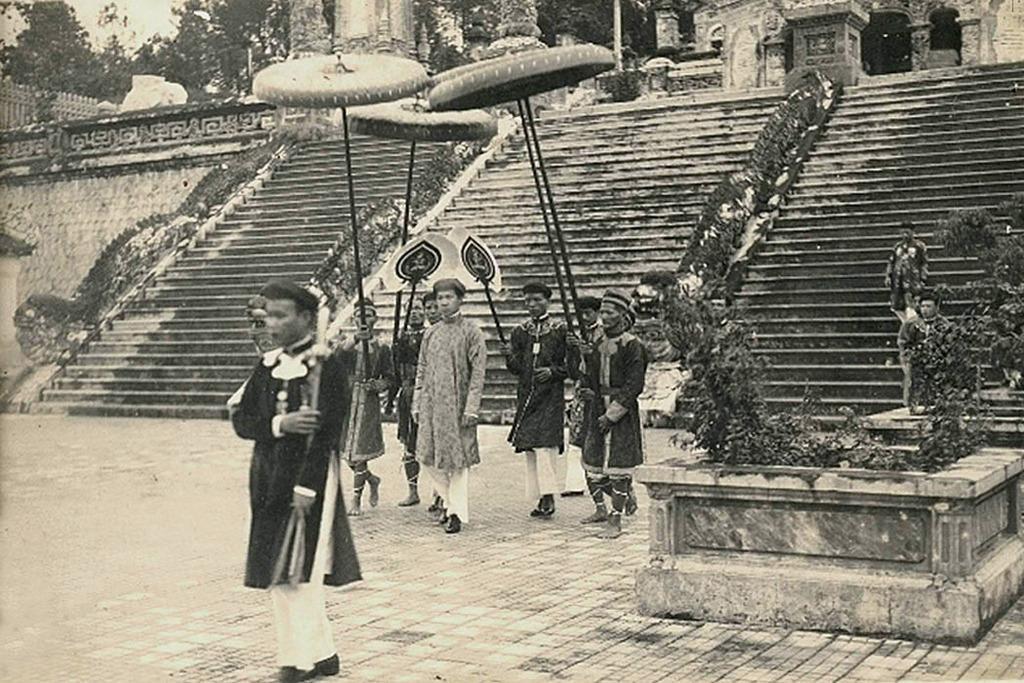In one or two sentences, can you explain what this image depicts? In this image in the center there are some people who are walking and they are holding some objects. In the background there are some stairs and buildings and trees. On the right side there are some plants, at the bottom there is walkway. 